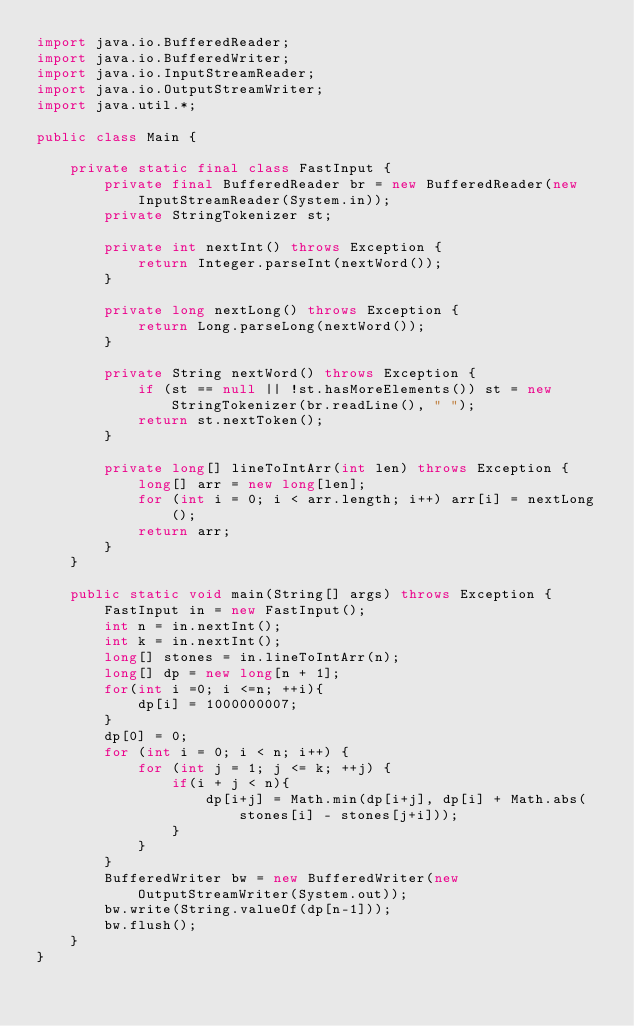<code> <loc_0><loc_0><loc_500><loc_500><_Java_>import java.io.BufferedReader;
import java.io.BufferedWriter;
import java.io.InputStreamReader;
import java.io.OutputStreamWriter;
import java.util.*;

public class Main {

    private static final class FastInput {
        private final BufferedReader br = new BufferedReader(new InputStreamReader(System.in));
        private StringTokenizer st;

        private int nextInt() throws Exception {
            return Integer.parseInt(nextWord());
        }

        private long nextLong() throws Exception {
            return Long.parseLong(nextWord());
        }

        private String nextWord() throws Exception {
            if (st == null || !st.hasMoreElements()) st = new StringTokenizer(br.readLine(), " ");
            return st.nextToken();
        }

        private long[] lineToIntArr(int len) throws Exception {
            long[] arr = new long[len];
            for (int i = 0; i < arr.length; i++) arr[i] = nextLong();
            return arr;
        }
    }

    public static void main(String[] args) throws Exception {
        FastInput in = new FastInput();
        int n = in.nextInt();
        int k = in.nextInt();
        long[] stones = in.lineToIntArr(n);
        long[] dp = new long[n + 1];
        for(int i =0; i <=n; ++i){
            dp[i] = 1000000007;
        }
        dp[0] = 0;
        for (int i = 0; i < n; i++) {
            for (int j = 1; j <= k; ++j) {
                if(i + j < n){
                    dp[i+j] = Math.min(dp[i+j], dp[i] + Math.abs(stones[i] - stones[j+i]));
                }
            }
        }
        BufferedWriter bw = new BufferedWriter(new OutputStreamWriter(System.out));
        bw.write(String.valueOf(dp[n-1]));
        bw.flush();
    }
}
</code> 